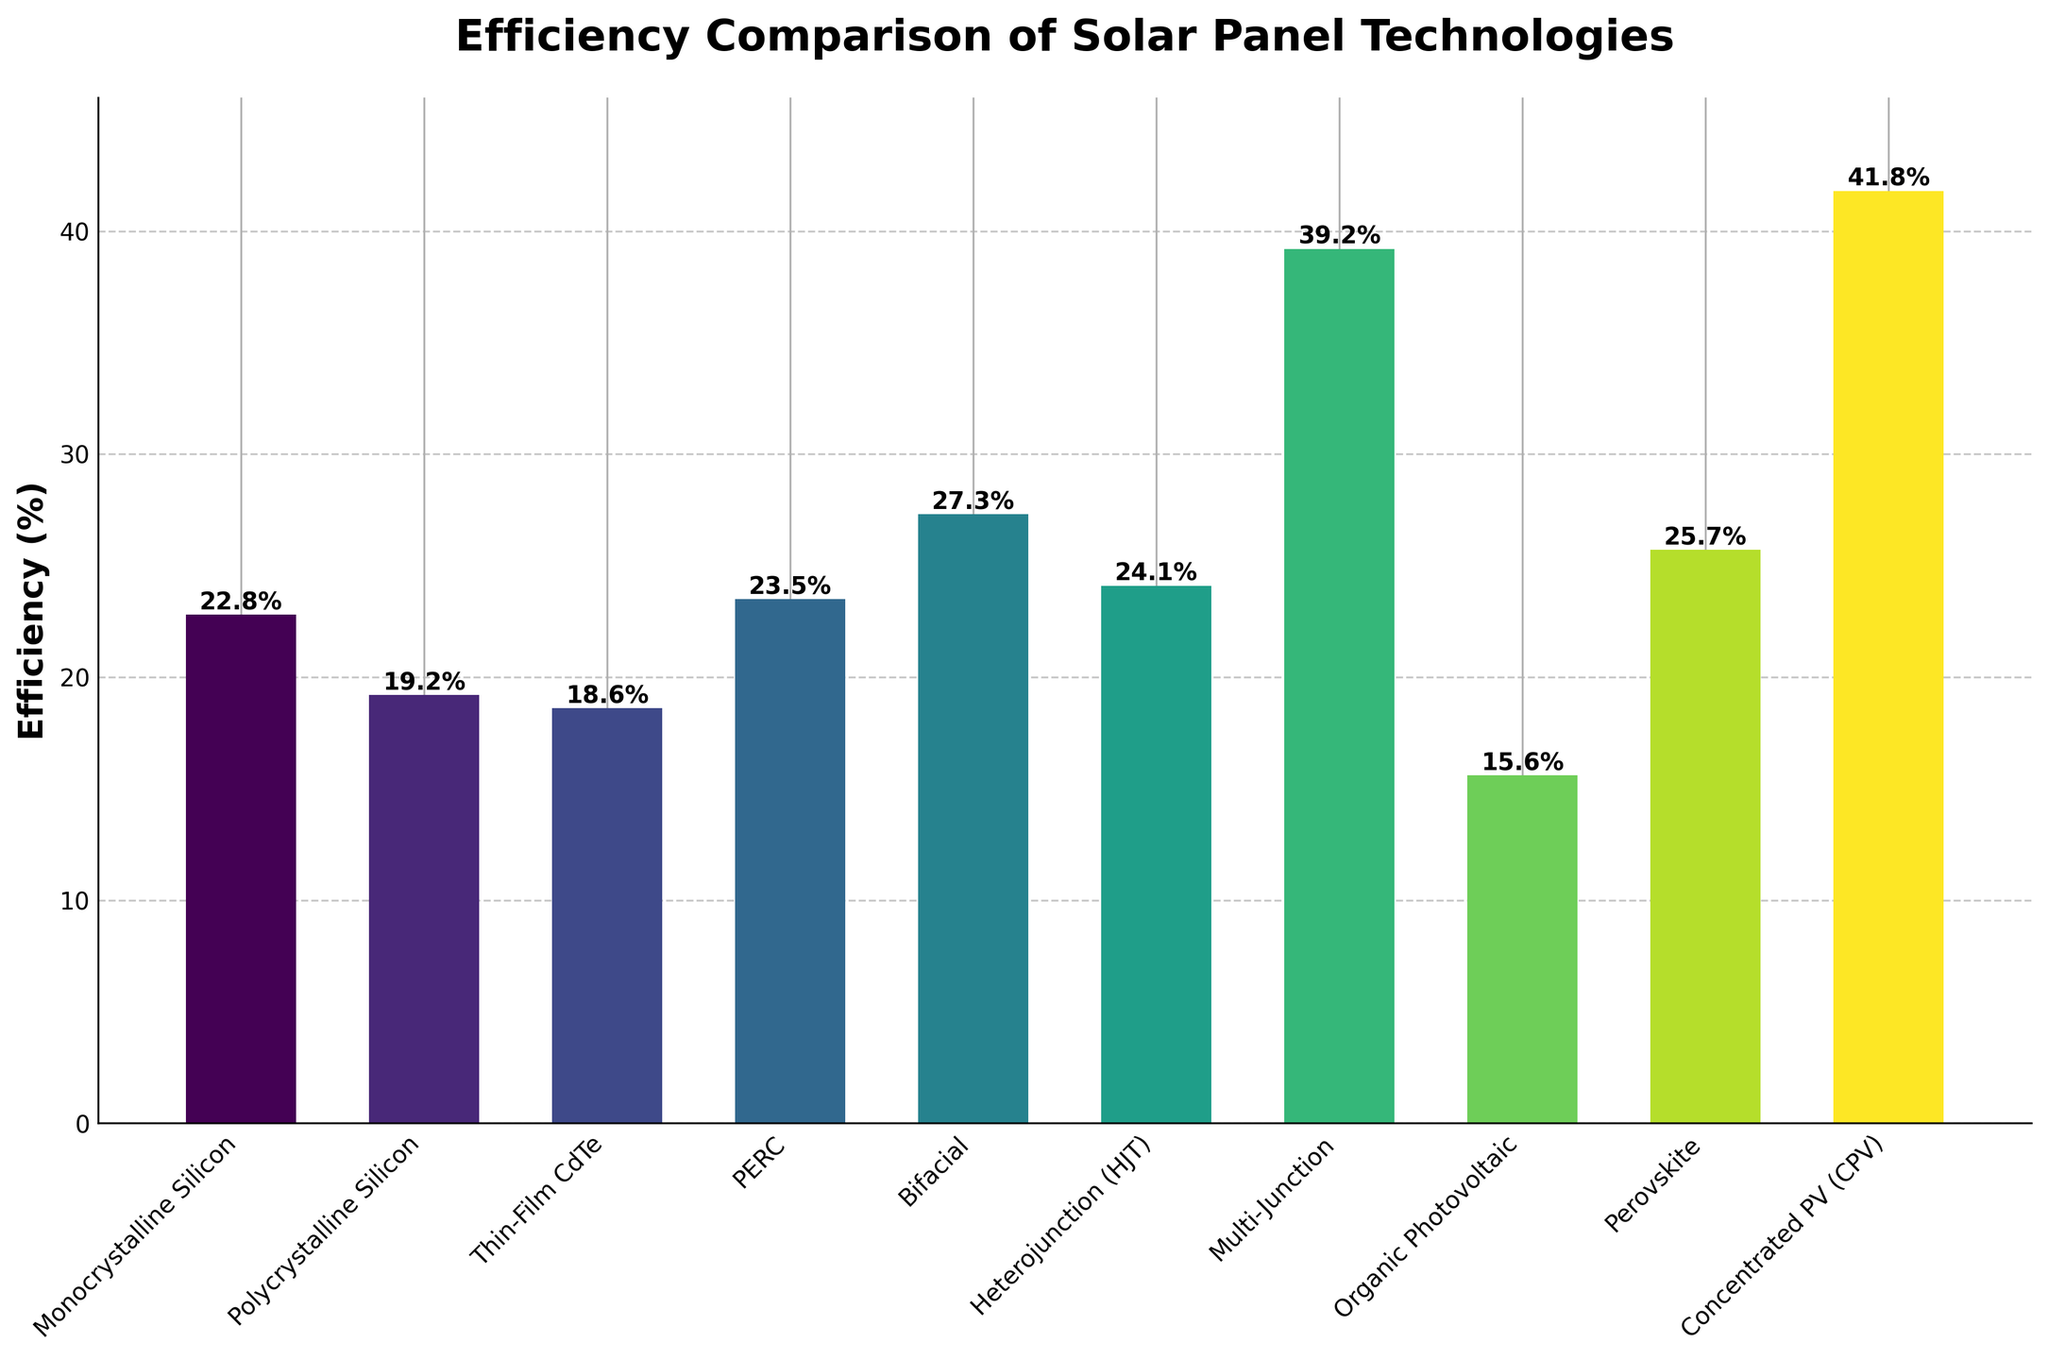What is the most efficient solar panel technology according to the figure? The bar representing "Concentrated PV (CPV)" is the tallest, indicating the highest efficiency. The exact value shown above the bar is 41.8%.
Answer: Concentrated PV (CPV) Which two technologies have efficiencies greater than 30%? The figure shows "Multi-Junction" with an efficiency of 39.2% and "Concentrated PV (CPV)" with 41.8%, both of which are greater than 30%.
Answer: Multi-Junction and Concentrated PV (CPV) What is the difference in efficiency between Monocrystalline Silicon and Polycrystalline Silicon? The figure shows that Monocrystalline Silicon has an efficiency of 22.8% and Polycrystalline Silicon has 19.2%. The difference is 22.8% - 19.2% = 3.6%.
Answer: 3.6% What is the average efficiency of the following three technologies: PERC, Bifacial, and Heterojunction (HJT)? The efficiencies of PERC, Bifacial, and Heterojunction (HJT) are 23.5%, 27.3%, and 24.1%, respectively. The average is calculated as (23.5 + 27.3 + 24.1) / 3 = 25.0%.
Answer: 25.0% Is Perovskite's efficiency greater than the average efficiency of Organic Photovoltaic and Thin-Film CdTe? The efficiencies are Perovskite: 25.7%, Organic Photovoltaic: 15.6%, and Thin-Film CdTe: 18.6%. The average of Organic Photovoltaic and Thin-Film CdTe is (15.6 + 18.6) / 2 = 17.1%. Since 25.7% > 17.1%, Perovskite's efficiency is greater.
Answer: Yes How many technologies have an efficiency greater than 25%? The technologies with efficiencies greater than 25% are Bifacial (27.3%), Heterojunction (HJT) (24.1%), Multi-Junction (39.2%), Perovskite (25.7%), and Concentrated PV (CPV) (41.8%). Count: 5 technologies.
Answer: 5 Compare the efficiency of Thin-Film CdTe and Organic Photovoltaic, and state which is more efficient. The figure shows that Thin-Film CdTe has an efficiency of 18.6%, while Organic Photovoltaic has 15.6%. Thin-Film CdTe is more efficient.
Answer: Thin-Film CdTe Which technology has the least efficiency, and what is its value? The shortest bar in the figure is for "Organic Photovoltaic," with an efficiency value of 15.6%, making it the least efficient technology.
Answer: Organic Photovoltaic, 15.6% What is the combined efficiency of Monocrystalline Silicon, PERC, and Bifacial panels? The efficiencies are Monocrystalline Silicon: 22.8%, PERC: 23.5%, and Bifacial: 27.3%. The combined efficiency is 22.8 + 23.5 + 27.3 = 73.6%.
Answer: 73.6% Which has a higher efficiency, Thin-Film CdTe or PERC, and by how much? Thin-Film CdTe has an efficiency of 18.6%, and PERC has 23.5%. The difference is 23.5% - 18.6% = 4.9%, meaning PERC has a higher efficiency by 4.9%.
Answer: PERC by 4.9% 